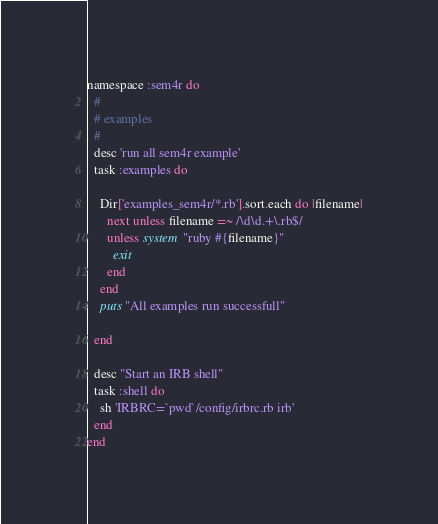Convert code to text. <code><loc_0><loc_0><loc_500><loc_500><_Ruby_>namespace :sem4r do
  #
  # examples
  #
  desc 'run all sem4r example'
  task :examples do

    Dir['examples_sem4r/*.rb'].sort.each do |filename|
      next unless filename =~ /\d\d.+\.rb$/
      unless system "ruby #{filename}"
        exit
      end
    end
    puts "All examples run successfull"

  end

  desc "Start an IRB shell"
  task :shell do
    sh 'IRBRC=`pwd`/config/irbrc.rb irb'
  end
end
</code> 